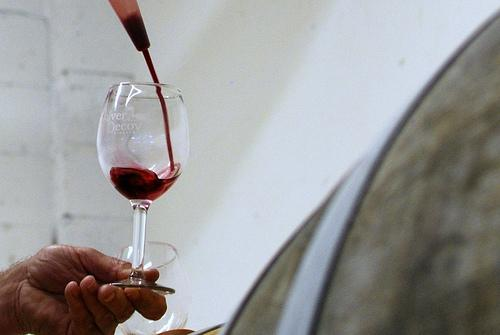Summarize the main activity taking place in the image. A man is pouring red wine into a glass he's holding, with a background of a white wall and a wooden wine barrel. Describe the colors and features of the elements in the image. A man's white hand holds a tall, clear wine glass with white writing, as red wine is poured into it, with a white wall and wooden barrel in the background. Mention the notable features of the wine glass and its contents. The wine glass has writings, a thin stem, a wide mouth, and a circular bottom, and is being filled with red wine. Illustrate the scene created by the image with emphasis on the wine glass. A tall and clear wine glass with writing on its side is being filled with red wine as it is held by a person's hand. Give an overview of the actions involving hands and wine in the image. A hand is holding the bottom of a wine glass and pouring red wine into it, in front of a white wall and a wooden barrel. Provide a concise overview of the image's main elements. Man, wine glass with text, pouring red wine, hand, white wall, wooden barrel with metal band. Narrate the ongoing event happening in the image including background elements. A man pours red wine from a bottle into a clear, tall wine glass with writing, positioned in front of a white brick wall and wooden barrel. Explain what action the man is doing while mentioning other objects. The man's left hand is holding a wine glass with text, as red wine pours into it, beside a white wall and wooden barrel. Provide a detailed explanation of the wine-related elements of the image. A wine glass with a winery's logo, held by a man, is being filled with red wine, while an empty glass sits near a wooden barrel in the background. Describe the visual representation of the hand in the image. The hand, appearing to be a man's, is holding the base of a wine glass, displaying wrinkles and a white complexion. 